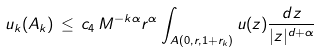<formula> <loc_0><loc_0><loc_500><loc_500>u _ { k } ( A _ { k } ) \, \leq \, c _ { 4 } \, M ^ { - k \alpha } r ^ { \alpha } \int _ { A ( 0 , r , 1 + r _ { k } ) } u ( z ) \frac { d z } { | z | ^ { d + \alpha } }</formula> 